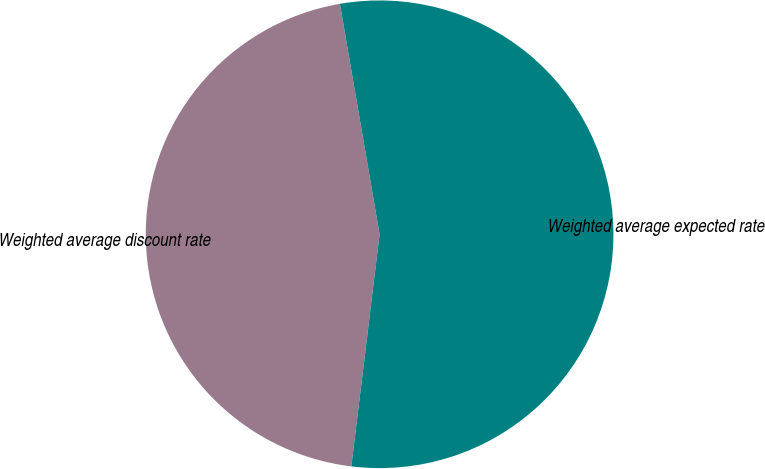Convert chart to OTSL. <chart><loc_0><loc_0><loc_500><loc_500><pie_chart><fcel>Weighted average discount rate<fcel>Weighted average expected rate<nl><fcel>45.36%<fcel>54.64%<nl></chart> 